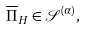Convert formula to latex. <formula><loc_0><loc_0><loc_500><loc_500>\overline { \Pi } _ { H } \in \mathcal { S } ^ { ( \alpha ) } ,</formula> 